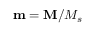<formula> <loc_0><loc_0><loc_500><loc_500>m = M / M _ { s }</formula> 